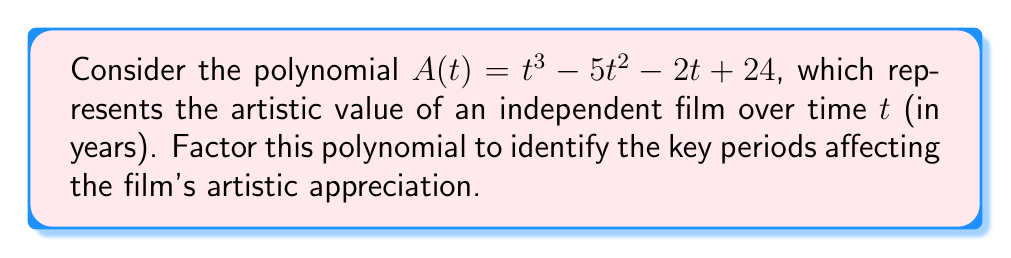Give your solution to this math problem. To factor this polynomial, we'll follow these steps:

1) First, let's check if there are any rational roots using the rational root theorem. The possible rational roots are the factors of the constant term: $\pm 1, \pm 2, \pm 3, \pm 4, \pm 6, \pm 8, \pm 12, \pm 24$.

2) Testing these values, we find that $t = 4$ is a root of the polynomial.

3) We can now divide the polynomial by $(t - 4)$:

   $$ \frac{t^3 - 5t^2 - 2t + 24}{t - 4} = t^2 - t - 6 $$

4) The quadratic factor $t^2 - t - 6$ can be factored further:
   
   $t^2 - t - 6 = (t - 3)(t + 2)$

5) Therefore, the complete factorization is:

   $$ A(t) = (t - 4)(t - 3)(t + 2) $$

This factorization reveals that the artistic value of the film reaches zero (i.e., crosses the time axis) at $t = 4$ and $t = 3$, and has a negative value at $t = -2$. These points represent critical periods in the film's artistic appreciation trajectory.
Answer: $A(t) = (t - 4)(t - 3)(t + 2)$ 